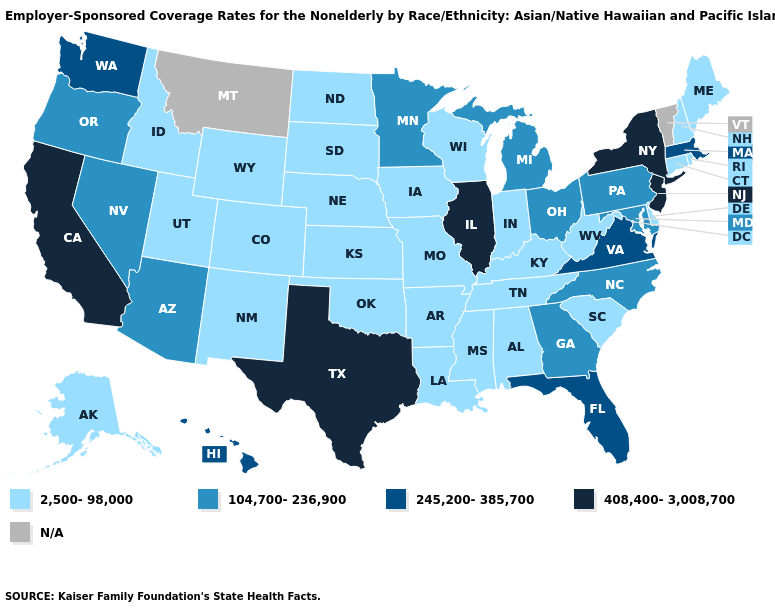Does Kansas have the highest value in the MidWest?
Answer briefly. No. What is the value of Virginia?
Keep it brief. 245,200-385,700. What is the highest value in the Northeast ?
Short answer required. 408,400-3,008,700. Name the states that have a value in the range N/A?
Write a very short answer. Montana, Vermont. Does Ohio have the highest value in the MidWest?
Keep it brief. No. Name the states that have a value in the range 104,700-236,900?
Answer briefly. Arizona, Georgia, Maryland, Michigan, Minnesota, Nevada, North Carolina, Ohio, Oregon, Pennsylvania. Which states hav the highest value in the MidWest?
Keep it brief. Illinois. Does the first symbol in the legend represent the smallest category?
Quick response, please. Yes. Does New Jersey have the lowest value in the Northeast?
Concise answer only. No. What is the value of Minnesota?
Answer briefly. 104,700-236,900. Name the states that have a value in the range 245,200-385,700?
Keep it brief. Florida, Hawaii, Massachusetts, Virginia, Washington. Is the legend a continuous bar?
Quick response, please. No. What is the value of Utah?
Concise answer only. 2,500-98,000. 